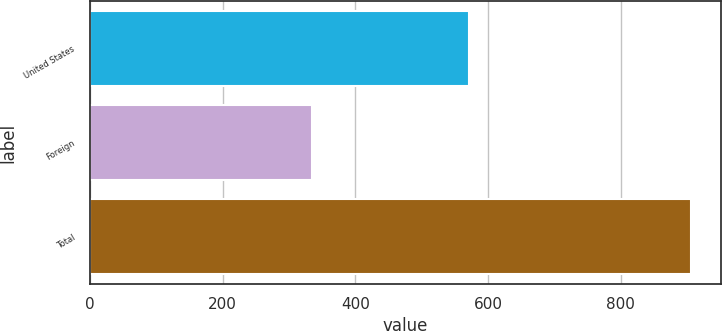Convert chart. <chart><loc_0><loc_0><loc_500><loc_500><bar_chart><fcel>United States<fcel>Foreign<fcel>Total<nl><fcel>571<fcel>335<fcel>906<nl></chart> 